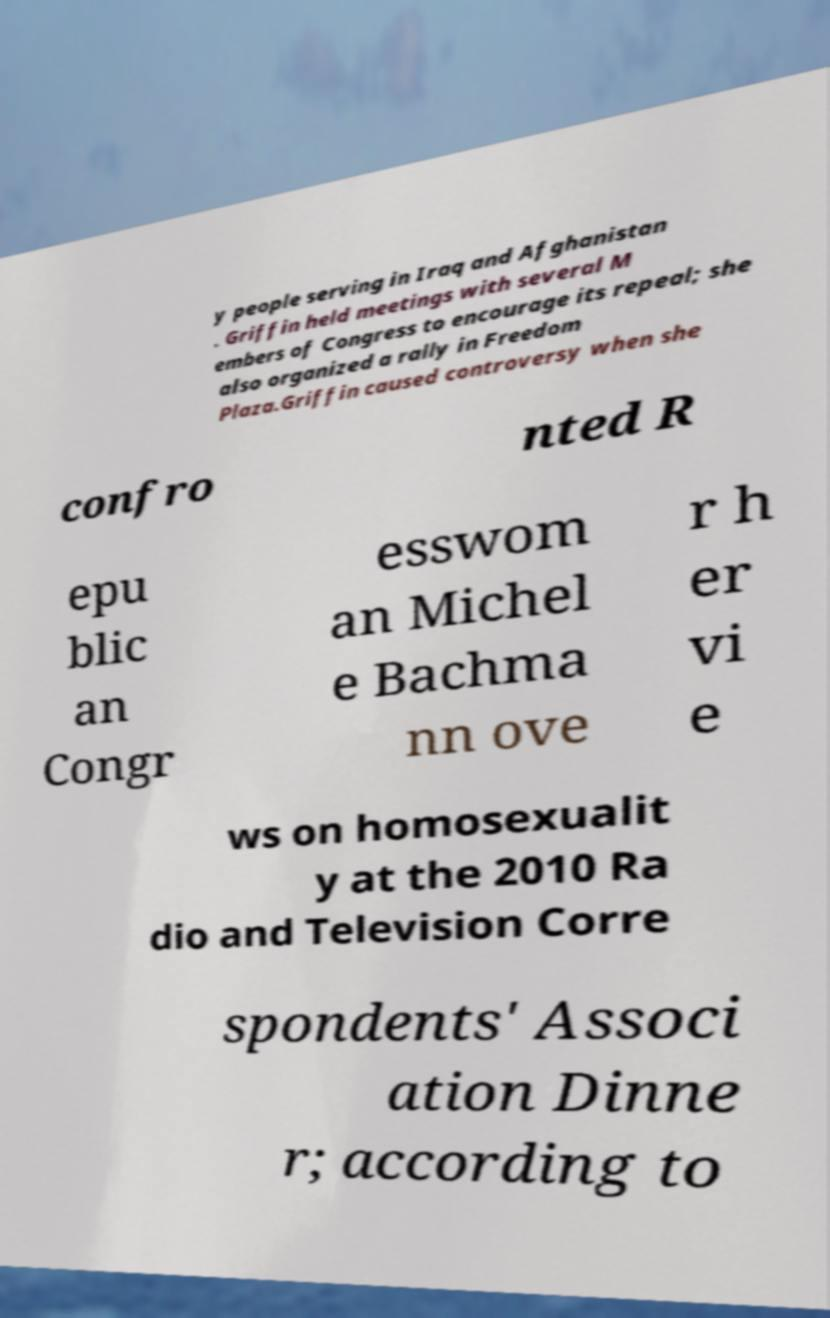Please identify and transcribe the text found in this image. y people serving in Iraq and Afghanistan . Griffin held meetings with several M embers of Congress to encourage its repeal; she also organized a rally in Freedom Plaza.Griffin caused controversy when she confro nted R epu blic an Congr esswom an Michel e Bachma nn ove r h er vi e ws on homosexualit y at the 2010 Ra dio and Television Corre spondents' Associ ation Dinne r; according to 